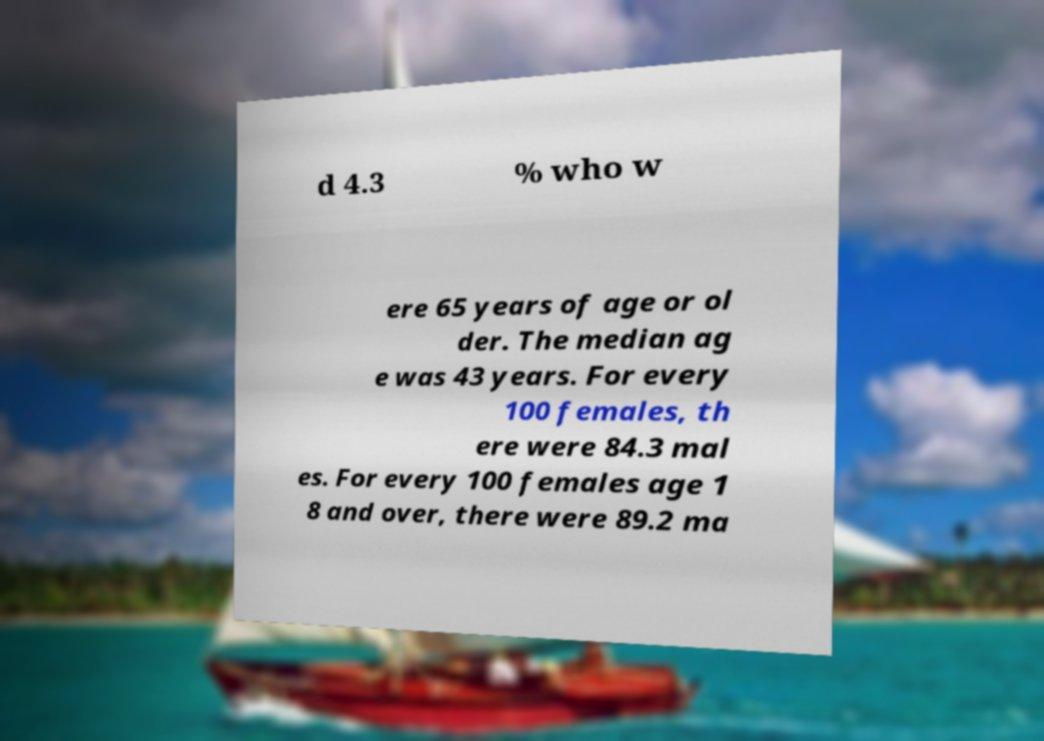Please identify and transcribe the text found in this image. d 4.3 % who w ere 65 years of age or ol der. The median ag e was 43 years. For every 100 females, th ere were 84.3 mal es. For every 100 females age 1 8 and over, there were 89.2 ma 